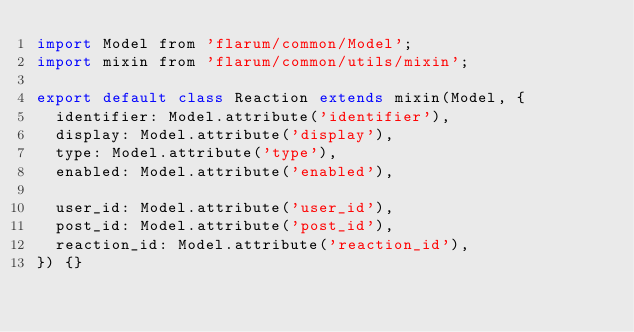Convert code to text. <code><loc_0><loc_0><loc_500><loc_500><_JavaScript_>import Model from 'flarum/common/Model';
import mixin from 'flarum/common/utils/mixin';

export default class Reaction extends mixin(Model, {
  identifier: Model.attribute('identifier'),
  display: Model.attribute('display'),
  type: Model.attribute('type'),
  enabled: Model.attribute('enabled'),

  user_id: Model.attribute('user_id'),
  post_id: Model.attribute('post_id'),
  reaction_id: Model.attribute('reaction_id'),
}) {}
</code> 